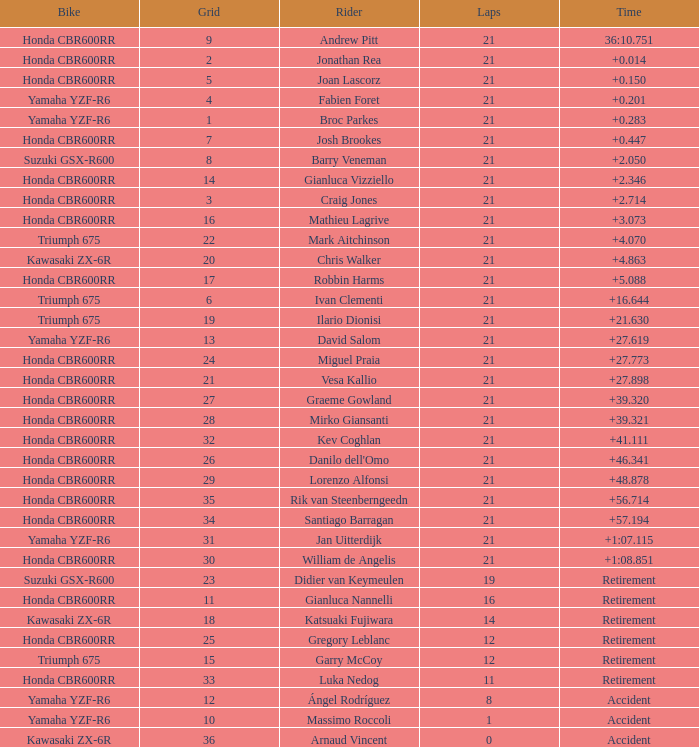What is the driver with the laps under 16, grid of 10, a bike of Yamaha YZF-R6, and ended with an accident? Massimo Roccoli. 